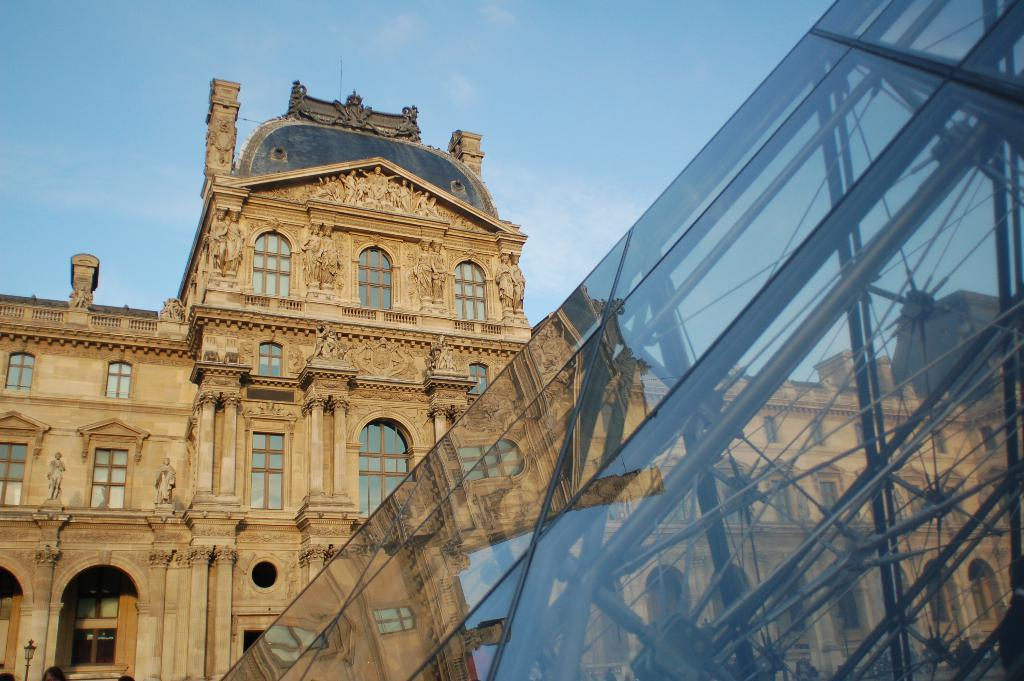What is the main subject of the image? The main subject of the image is a large construction. Can you describe the construction in more detail? The construction is a beautiful building with many carvings. What architectural features can be seen on the building? The building has multiple windows. What else can be seen in the image related to the building? There is class equipment visible in the image. Who is the creator of the need in the image? There is no mention of a "need" in the image, and therefore no creator can be identified. 